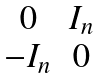Convert formula to latex. <formula><loc_0><loc_0><loc_500><loc_500>\begin{matrix} 0 & I _ { n } \\ - I _ { n } & 0 \end{matrix}</formula> 